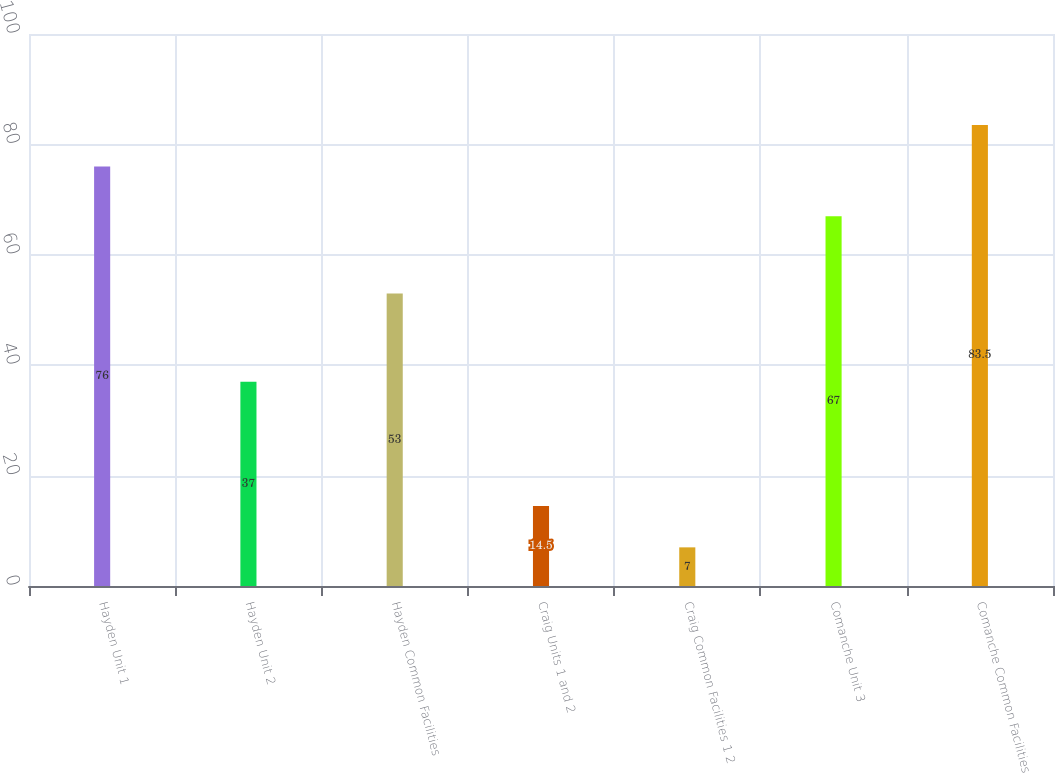<chart> <loc_0><loc_0><loc_500><loc_500><bar_chart><fcel>Hayden Unit 1<fcel>Hayden Unit 2<fcel>Hayden Common Facilities<fcel>Craig Units 1 and 2<fcel>Craig Common Facilities 1 2<fcel>Comanche Unit 3<fcel>Comanche Common Facilities<nl><fcel>76<fcel>37<fcel>53<fcel>14.5<fcel>7<fcel>67<fcel>83.5<nl></chart> 